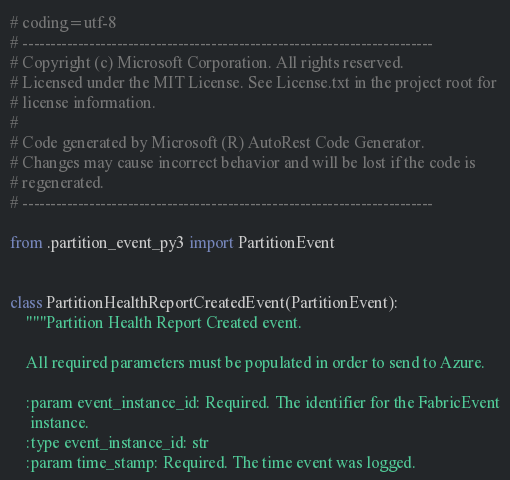<code> <loc_0><loc_0><loc_500><loc_500><_Python_># coding=utf-8
# --------------------------------------------------------------------------
# Copyright (c) Microsoft Corporation. All rights reserved.
# Licensed under the MIT License. See License.txt in the project root for
# license information.
#
# Code generated by Microsoft (R) AutoRest Code Generator.
# Changes may cause incorrect behavior and will be lost if the code is
# regenerated.
# --------------------------------------------------------------------------

from .partition_event_py3 import PartitionEvent


class PartitionHealthReportCreatedEvent(PartitionEvent):
    """Partition Health Report Created event.

    All required parameters must be populated in order to send to Azure.

    :param event_instance_id: Required. The identifier for the FabricEvent
     instance.
    :type event_instance_id: str
    :param time_stamp: Required. The time event was logged.</code> 